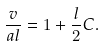Convert formula to latex. <formula><loc_0><loc_0><loc_500><loc_500>\frac { v } { a l } = 1 + \frac { l } { 2 } C .</formula> 